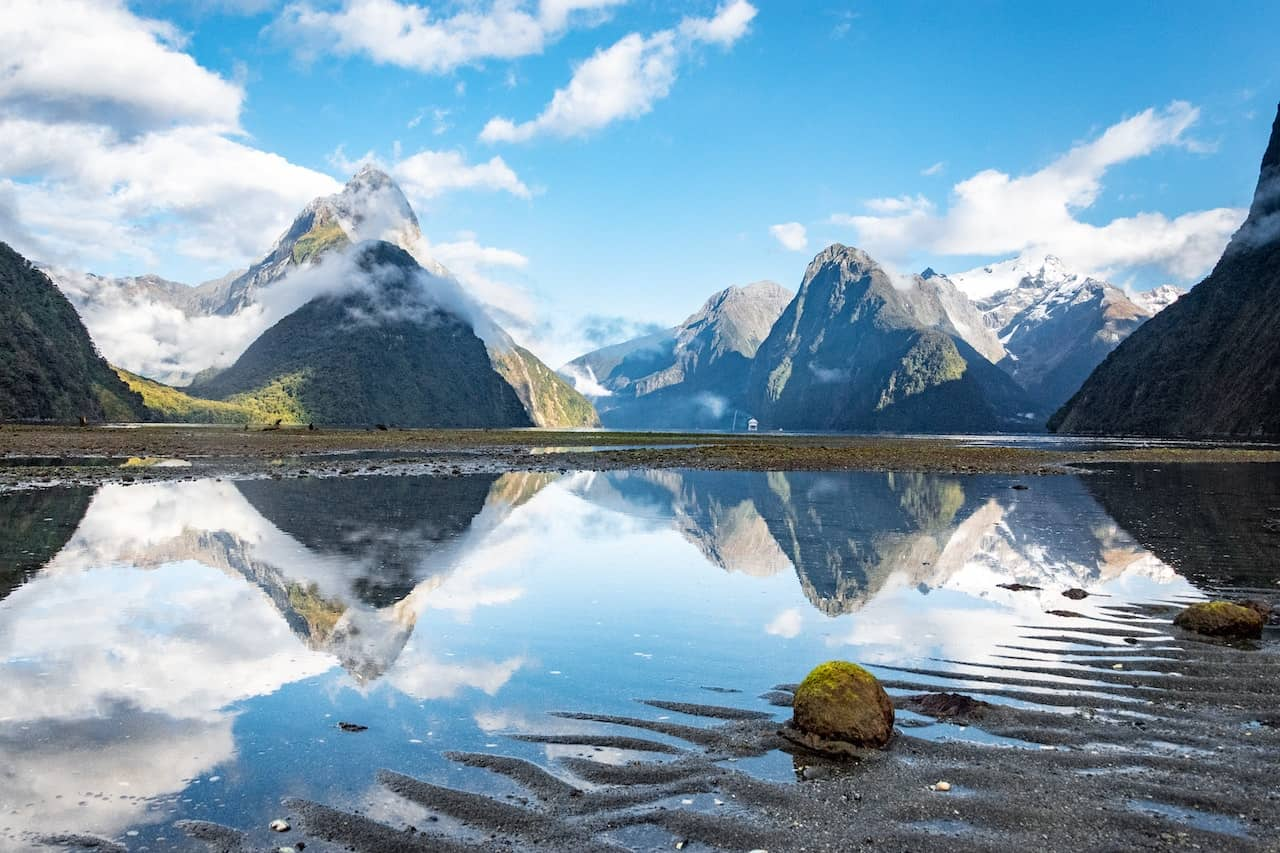Describe the following image. This image showcases the majestic Milford Sound in New Zealand, characterized by its dramatic natural scenery. A key feature of this landscape is the iconic Mitre Peak, rising sharply in the center against a backdrop of rugged cliffs and pristine snowy peaks. The image is taken from a unique low angle, emphasizing the grand scale of the mountains which dominate the skyline. The sky, a vivid blue with sparse, fluffy clouds, adds a dynamic element to the composition. Below, the sound's waters are remarkably calm, mirroring the mountains and sky with perfect symmetry, creating a serene, almost surreal scene. The foreground features a sand-strewn shore dotted with small rocks, some covered in bright green moss, adding a splash of color to the predominantly blue and white palette. This image not only captures the tranquil beauty of Milford Sound but also elicits a sense of wonder at the untouched wilderness. 